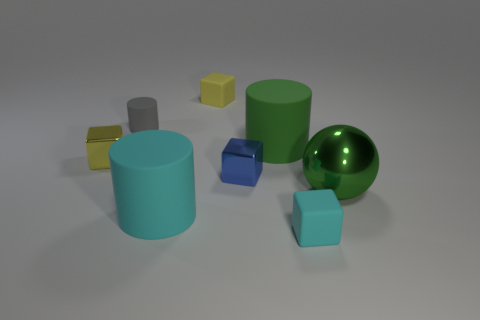Subtract all cylinders. How many objects are left? 5 Subtract 2 blocks. How many blocks are left? 2 Subtract all blue cylinders. Subtract all yellow spheres. How many cylinders are left? 3 Subtract all brown balls. How many blue blocks are left? 1 Subtract all brown spheres. Subtract all small shiny things. How many objects are left? 6 Add 4 cyan cubes. How many cyan cubes are left? 5 Add 1 large green balls. How many large green balls exist? 2 Add 1 big brown matte objects. How many objects exist? 9 Subtract all cyan cylinders. How many cylinders are left? 2 Subtract all yellow shiny cubes. How many cubes are left? 3 